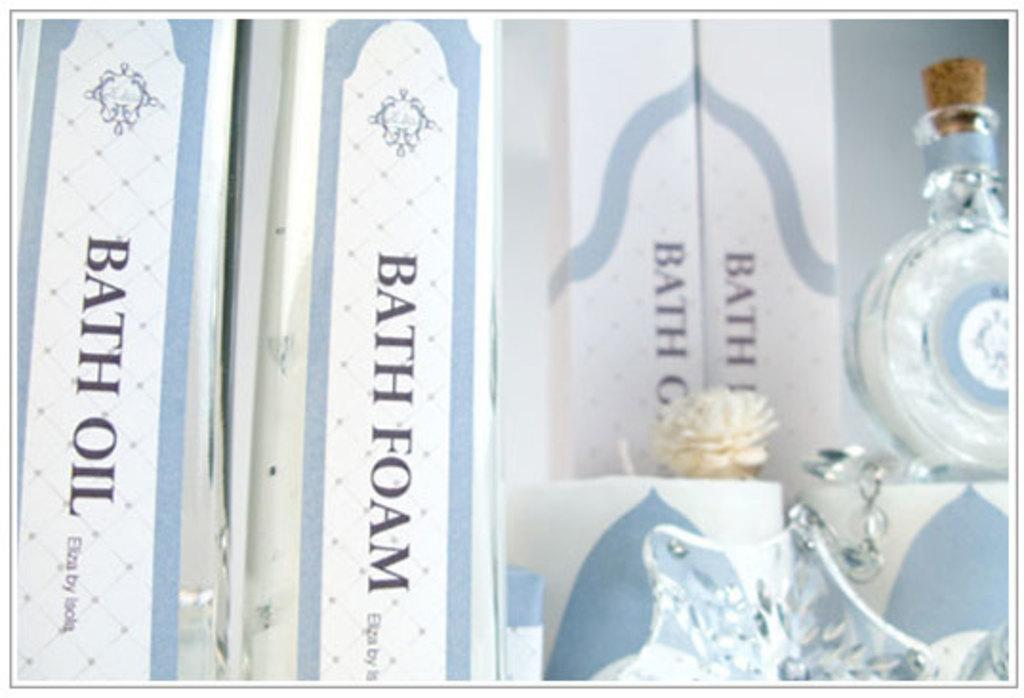<image>
Give a short and clear explanation of the subsequent image. Bath foam and bath oil with perfume also 